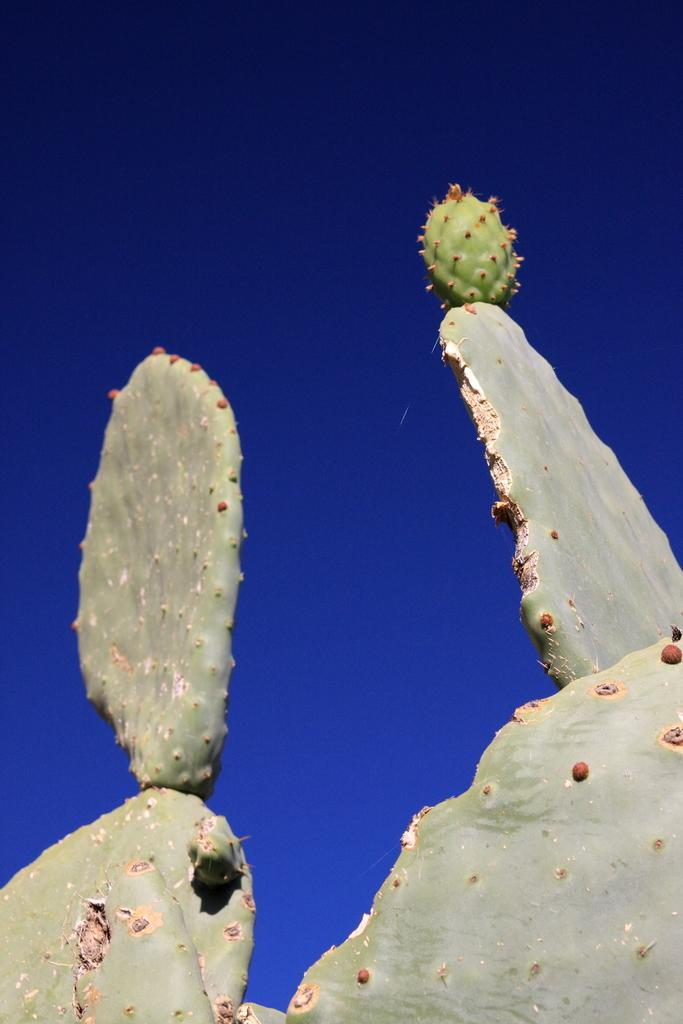What type of plant is in the image? There is a cactus plant in the image. What is visible at the top of the image? The sky is visible at the top of the image. What type of tool is the carpenter using in the image? There is no carpenter or tool present in the image; it only features a cactus plant and the sky. How long does it take for the hook to appear in the image? There is no hook present in the image, so it cannot be determined how long it would take for it to appear. 